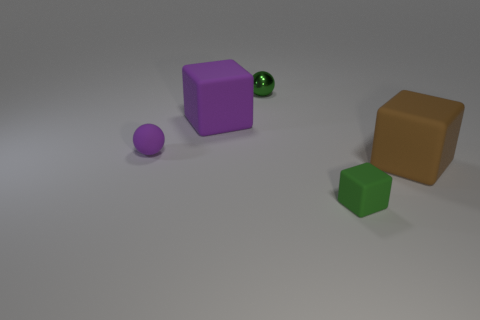If the small purple sphere started rolling towards the green cube, which object would it encounter first? Observing the positions of the objects in the image, if the small purple sphere were to roll toward the green cube, it would directly encounter the large purple cube first, since it is in its immediate path. 